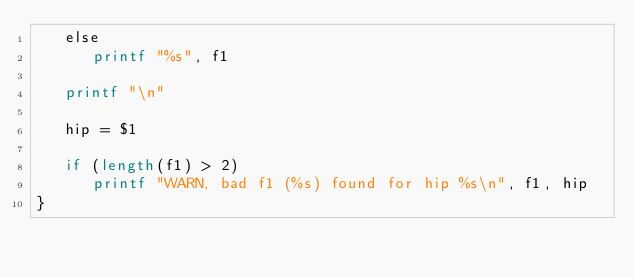<code> <loc_0><loc_0><loc_500><loc_500><_Awk_>   else
      printf "%s", f1

   printf "\n"

   hip = $1

   if (length(f1) > 2)
      printf "WARN, bad f1 (%s) found for hip %s\n", f1, hip
}
</code> 